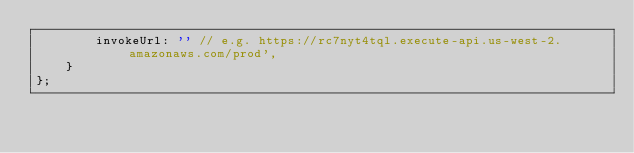<code> <loc_0><loc_0><loc_500><loc_500><_JavaScript_>        invokeUrl: '' // e.g. https://rc7nyt4tql.execute-api.us-west-2.amazonaws.com/prod',
    }
};
</code> 